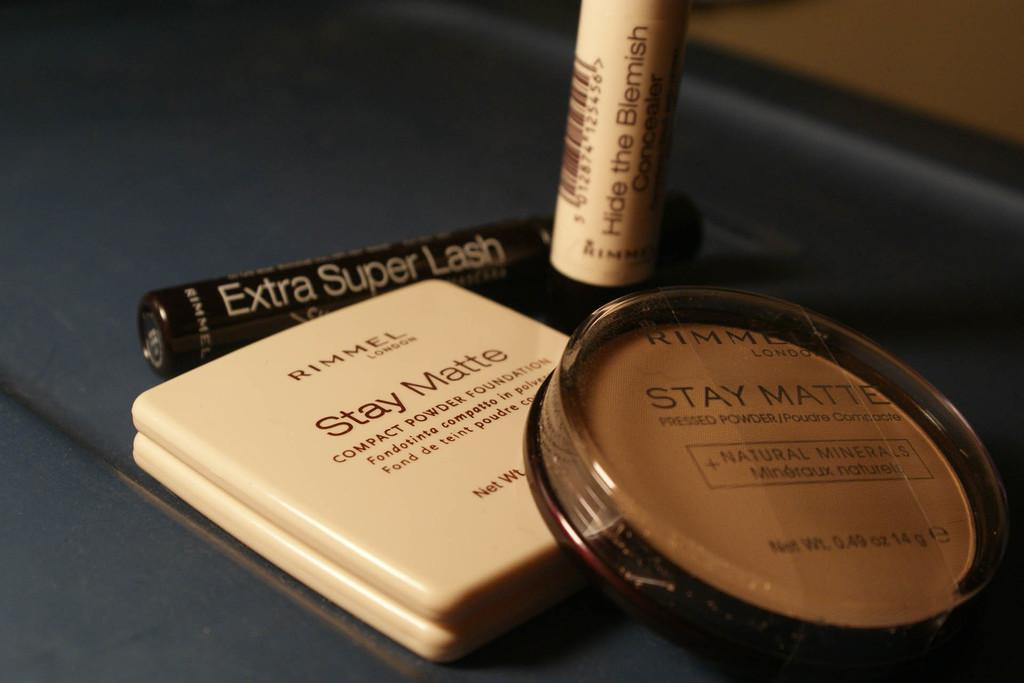<image>
Share a concise interpretation of the image provided. the word stay is on the brown item on the blue surface 